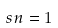<formula> <loc_0><loc_0><loc_500><loc_500>s n = 1</formula> 